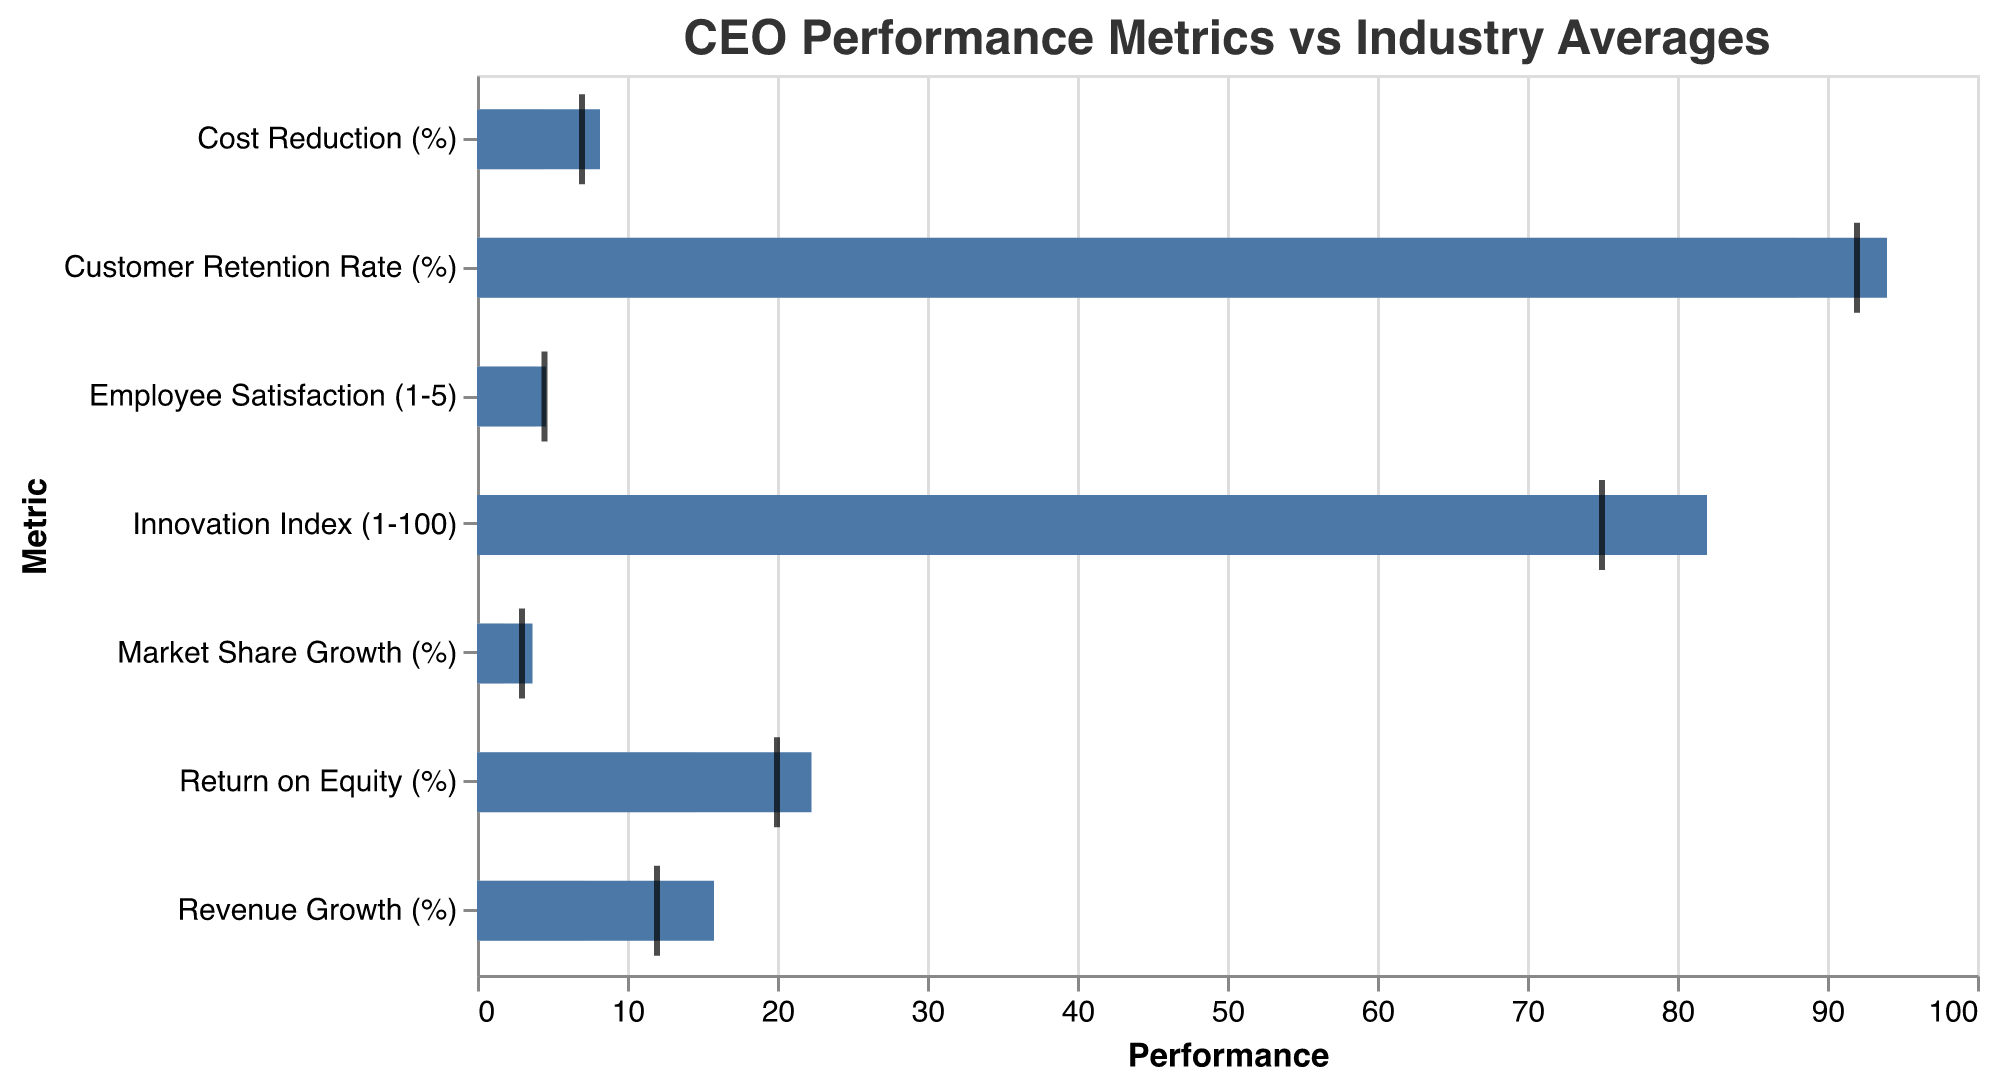What is the title of the figure? The title is located at the top center of the figure and reads "CEO Performance Metrics vs Industry Averages".
Answer: CEO Performance Metrics vs Industry Averages Which metric has the highest CEO performance value? By looking at the lengths of the blue bars representing CEO Performance, the "Customer Retention Rate (%)" has the highest value.
Answer: Customer Retention Rate (%) Which metric shows the smallest gap between the CEO performance and the target? To identify the smallest gap, look for the tick mark (representing the target) that is closest to the end of the blue bar (representing the CEO performance). The closest metric is "Market Share Growth (%)".
Answer: Market Share Growth (%) Which metrics have CEO performances that exceed the target? Compare the end of the blue bars (CEO Performance) with the positions of the tick marks (Target). The metrics where the blue bars extend beyond the tick marks are "Revenue Growth (%)", "Return on Equity (%)", "Employee Satisfaction (1-5)", "Customer Retention Rate (%)"
Answer: Revenue Growth (%), Return on Equity (%), Employee Satisfaction (1-5), Customer Retention Rate (%) On which metric does the CEO outperform the industry average the most? Look at the grey bars (Industry Average) and calculate the differences between the end of the blue bars and the grey bars. The largest gap indicates the greatest outperformance, which is "Return on Equity (%)".
Answer: Return on Equity (%) How many metrics have a higher CEO performance than the industry average? Compare each blue bar (CEO Performance) with its corresponding grey bar (Industry Average). All metrics have blue bars extending beyond grey bars, indicating that the CEO performance is higher in all cases. Count these metrics to get the total. There are 7 metrics in total.
Answer: 7 By how much does the CEO outperform the industry average in Employee Satisfaction? Subtract the industry average value from the CEO performance value for Employee Satisfaction: 4.6 (CEO Performance) - 3.9 (Industry Average) = 0.7
Answer: 0.7 In terms of Market Share Growth (%), how does the CEO performance compare to the industry average and target? The CEO performance is represented by the blue bar, the industry average by the grey bar, and the target by the tick mark. For Market Share Growth (%): CEO Performance is 3.7%, Industry Average is 1.8%, and Target is 3%. The CEO performance exceeds both the industry average and the target.
Answer: Exceeds both 